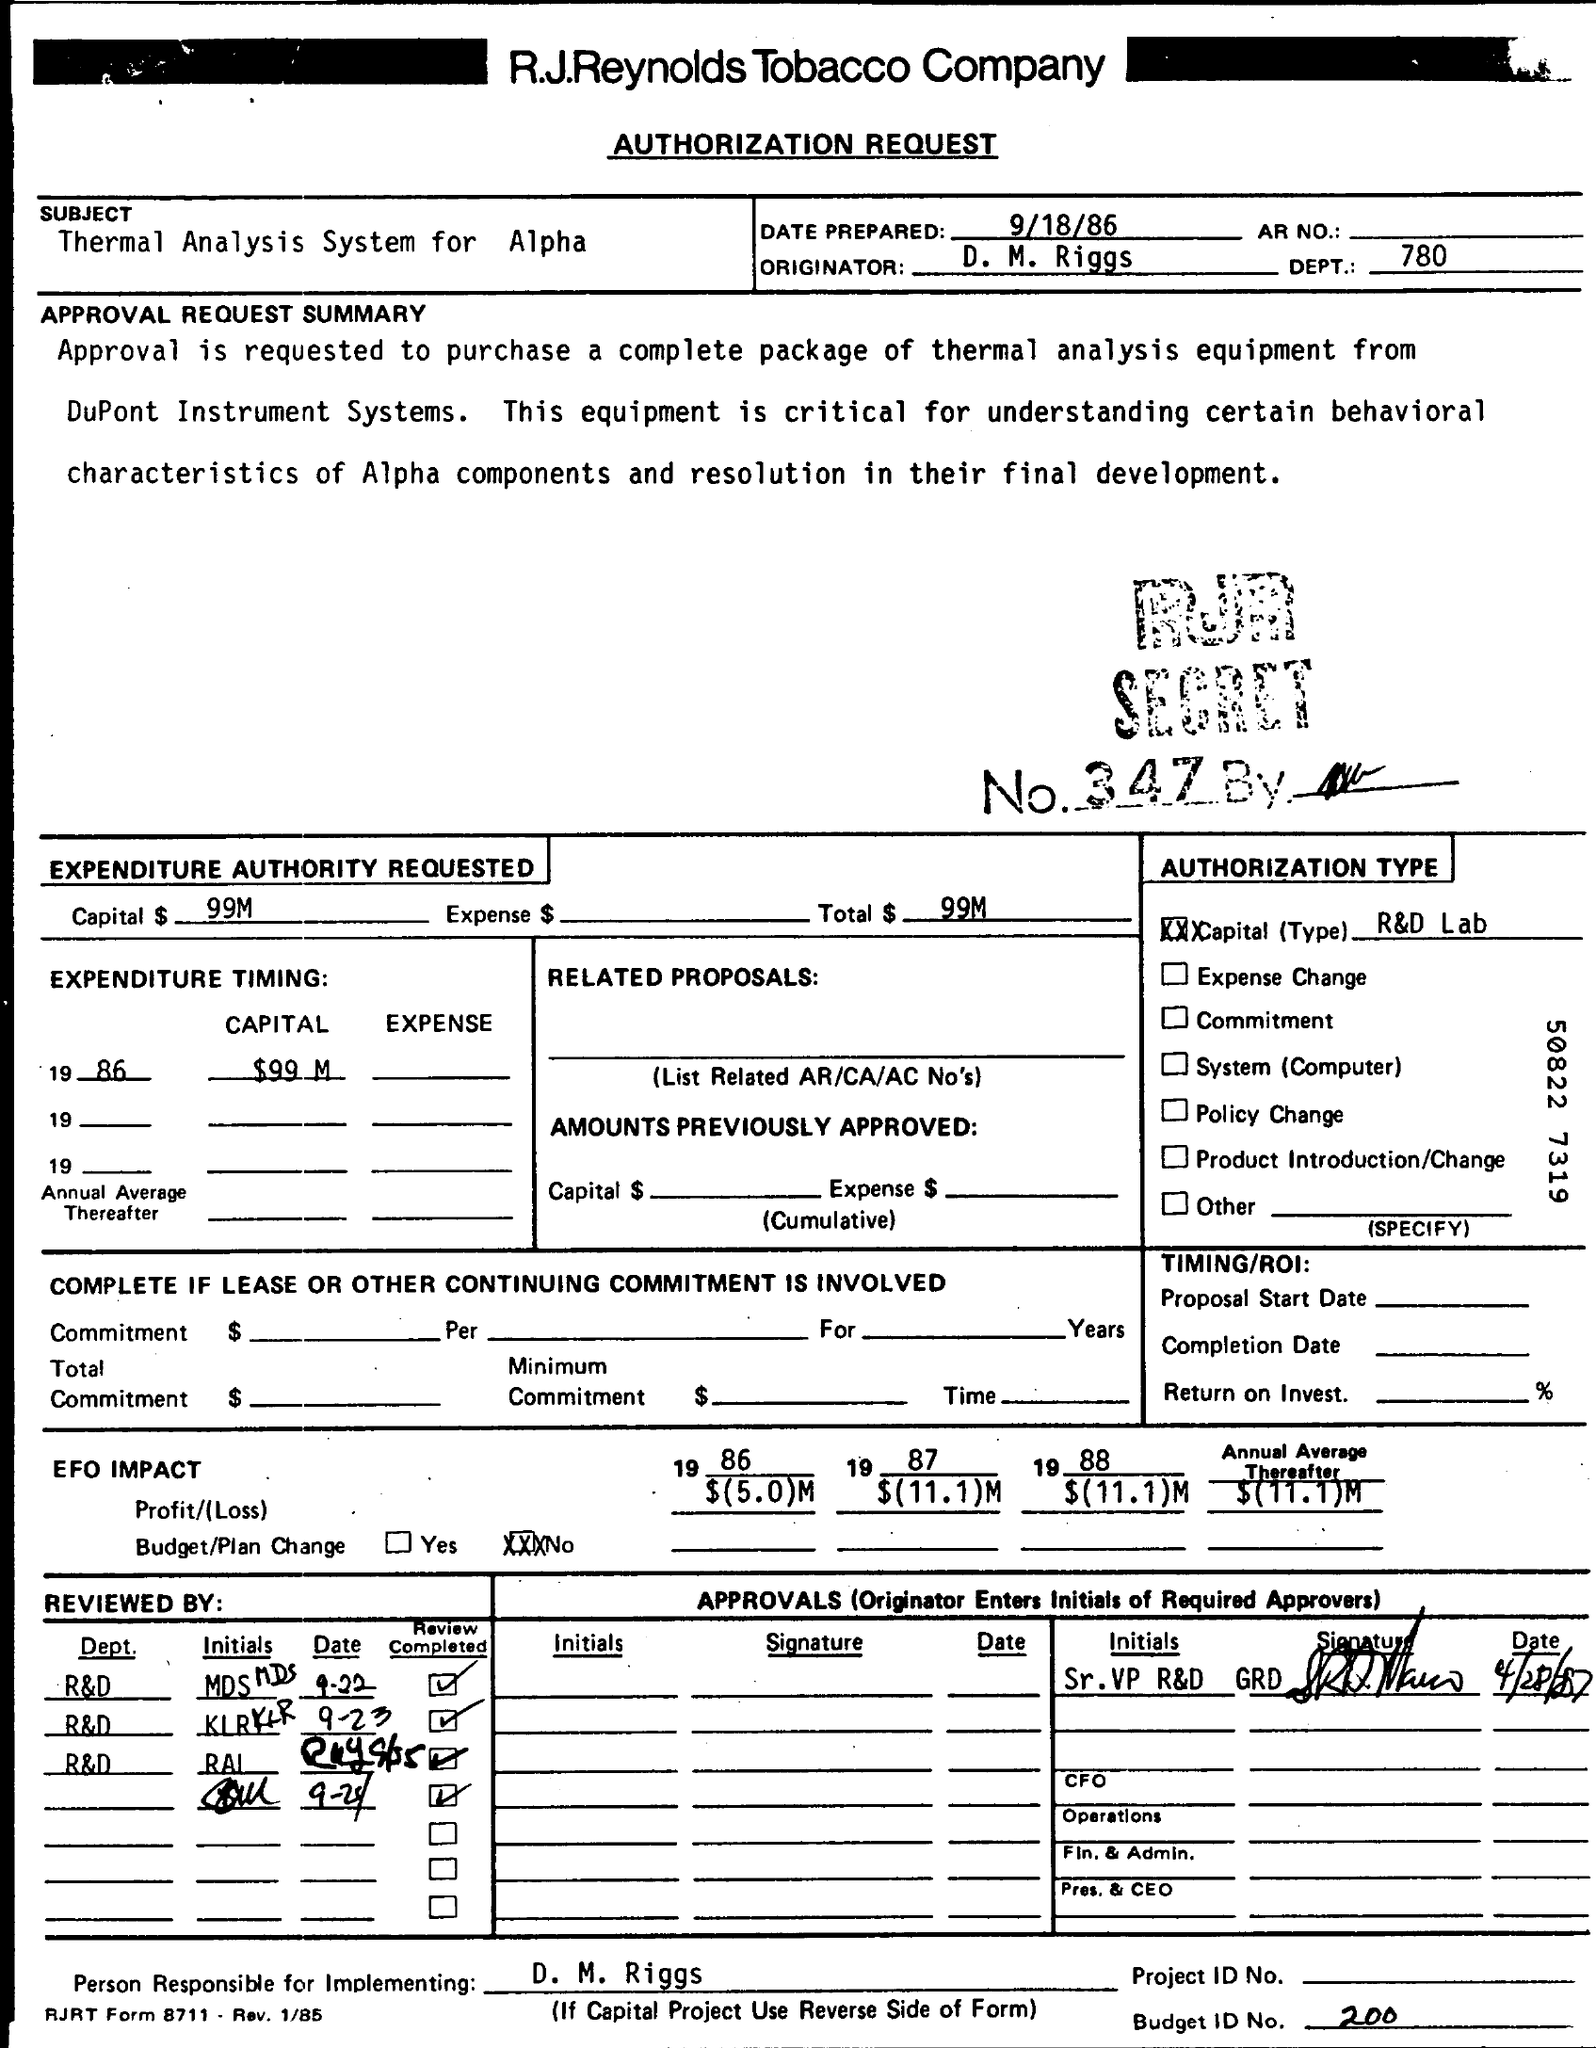Mention a couple of crucial points in this snapshot. The subject of the letter is the thermal analysis system for alpha-spin coating. The budget ID number is 200... The originator is D. M. Riggs. 